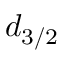Convert formula to latex. <formula><loc_0><loc_0><loc_500><loc_500>d _ { 3 / 2 }</formula> 